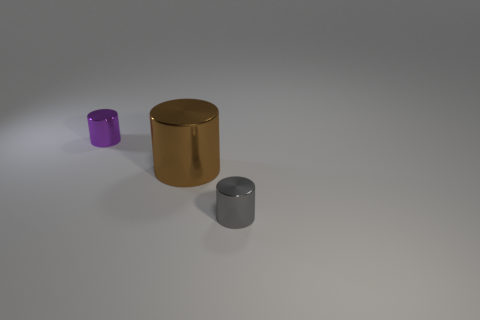There is a purple thing; what number of small shiny things are behind it?
Ensure brevity in your answer.  0. Is the number of brown metallic cylinders less than the number of blue cylinders?
Offer a very short reply. No. There is a metallic cylinder that is both behind the gray thing and in front of the purple cylinder; what size is it?
Provide a short and direct response. Large. There is a small shiny object behind the big brown object; does it have the same color as the big metal cylinder?
Your answer should be very brief. No. Are there fewer objects in front of the brown object than large red rubber blocks?
Keep it short and to the point. No. There is a gray thing that is the same material as the brown thing; what is its shape?
Your response must be concise. Cylinder. Is the brown object made of the same material as the purple object?
Offer a terse response. Yes. Is the number of big brown metal cylinders that are left of the brown metallic cylinder less than the number of gray objects that are behind the gray metal cylinder?
Provide a short and direct response. No. There is a small shiny cylinder behind the small object in front of the purple cylinder; what number of small purple shiny cylinders are left of it?
Your response must be concise. 0. Is there another large metallic thing of the same color as the big thing?
Offer a very short reply. No. 